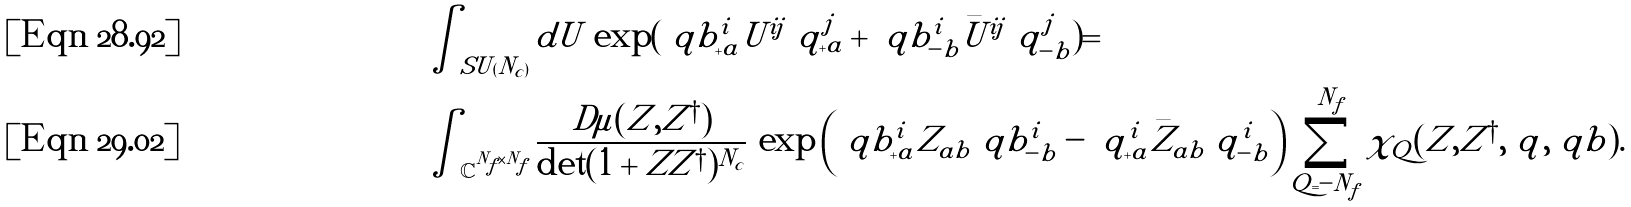<formula> <loc_0><loc_0><loc_500><loc_500>& \int _ { S U ( N _ { c } ) } d U \, \exp ( \ q b _ { + a } ^ { i } U ^ { i j } \ q _ { + a } ^ { j } + \ q b _ { - b } ^ { i } \bar { U } ^ { i j } \ q _ { - b } ^ { j } ) = \\ & \int _ { \mathbb { C } ^ { N _ { f } \times N _ { f } } } \frac { D \mu ( Z , Z ^ { \dagger } ) } { \det ( 1 + Z Z ^ { \dagger } ) ^ { N _ { c } } } \, \exp \left ( \ q b _ { + a } ^ { i } Z _ { a b } \ q b _ { - b } ^ { i } - \ q _ { + a } ^ { i } \bar { Z } _ { a b } \ q _ { - b } ^ { i } \right ) \sum _ { Q = - N _ { f } } ^ { N _ { f } } \chi _ { Q } ( Z , Z ^ { \dagger } , \ q , \ q b ) .</formula> 